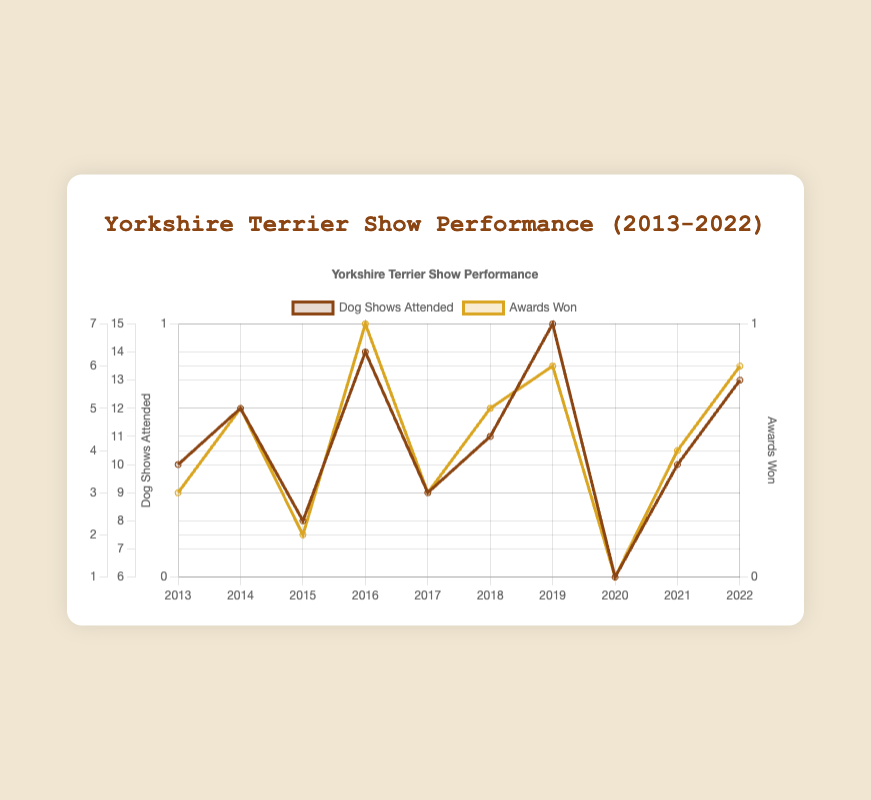What year saw the highest number of dog shows attended? The highest point on the "Dog Shows Attended" line where the value reached its maximum indicates the year. Observing the chart, the peak number is 15, which corresponds to the year 2019.
Answer: 2019 What is the overall trend in the number of awards won from 2013 to 2022? The line representing "Awards Won" shows fluctuations up and down. To identify the overall trend, we observe the starting and ending points. The awards start at 3 in 2013 and end higher at 6 in 2022, indicating an increasing trend.
Answer: Increasing In which year was the ratio of awards won to shows attended the highest? Calculate the ratio of awards to shows for each year. The highest ratio would be the maximum value among these calculations:
2013: 3/10 = 0.3
2014: 5/12 ≈ 0.417
2015: 2/8 = 0.25
2016: 7/14 = 0.5
2017: 3/9 ≈ 0.333
2018: 5/11 ≈ 0.455
2019: 6/15 = 0.4
2020: 1/6 ≈ 0.167
2021: 4/10 = 0.4
2022: 6/13 ≈ 0.462
The highest ratio is 0.5 in 2016.
Answer: 2016 By how much did the number of awards won change from 2015 to 2016? Subtract the number of awards won in 2015 from the number won in 2016 (7 - 2).
Answer: 5 Which year had the lowest number of awards won and what was that number? Look for the minimum point on the "Awards Won" line, which represents the year with the least awards won. The lowest value is 1, occurring in 2020.
Answer: 2020, 1 How does the number of dog shows attended in 2020 compare to 2019? Compare the values for "Dog Shows Attended" between the two years: 15 (2019) and 6 (2020). The number decreased from 15 to 6.
Answer: Decreased What is the average number of awards won per year over the decade? Sum the awards won each year and divide by the number of years:
(3+5+2+7+3+5+6+1+4+6) / 10 = 42 / 10 = 4.2
Answer: 4.2 Identify the year with the largest dip in the number of dog shows attended. What is the difference between the years before and after the dip? The largest dip is from 2019 to 2020, dropping from 15 to 6. The difference in shows attended is 15 - 6 = 9.
Answer: 2020, 9 